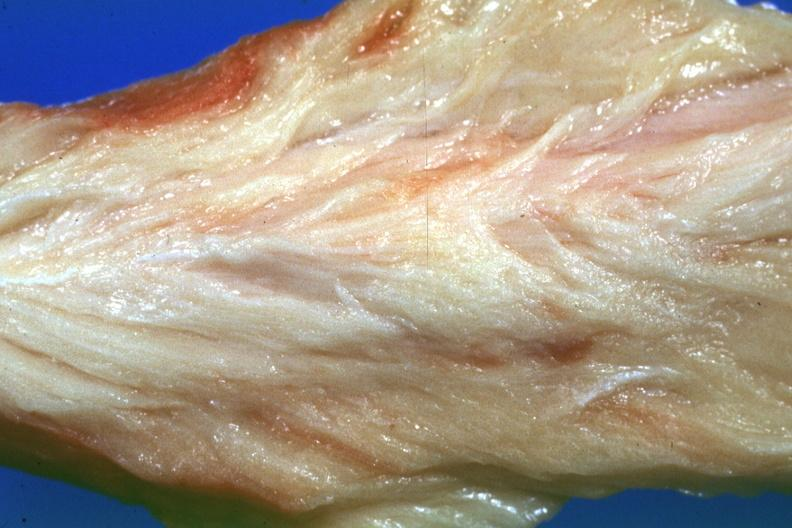does this image show close-up very pale muscle?
Answer the question using a single word or phrase. Yes 